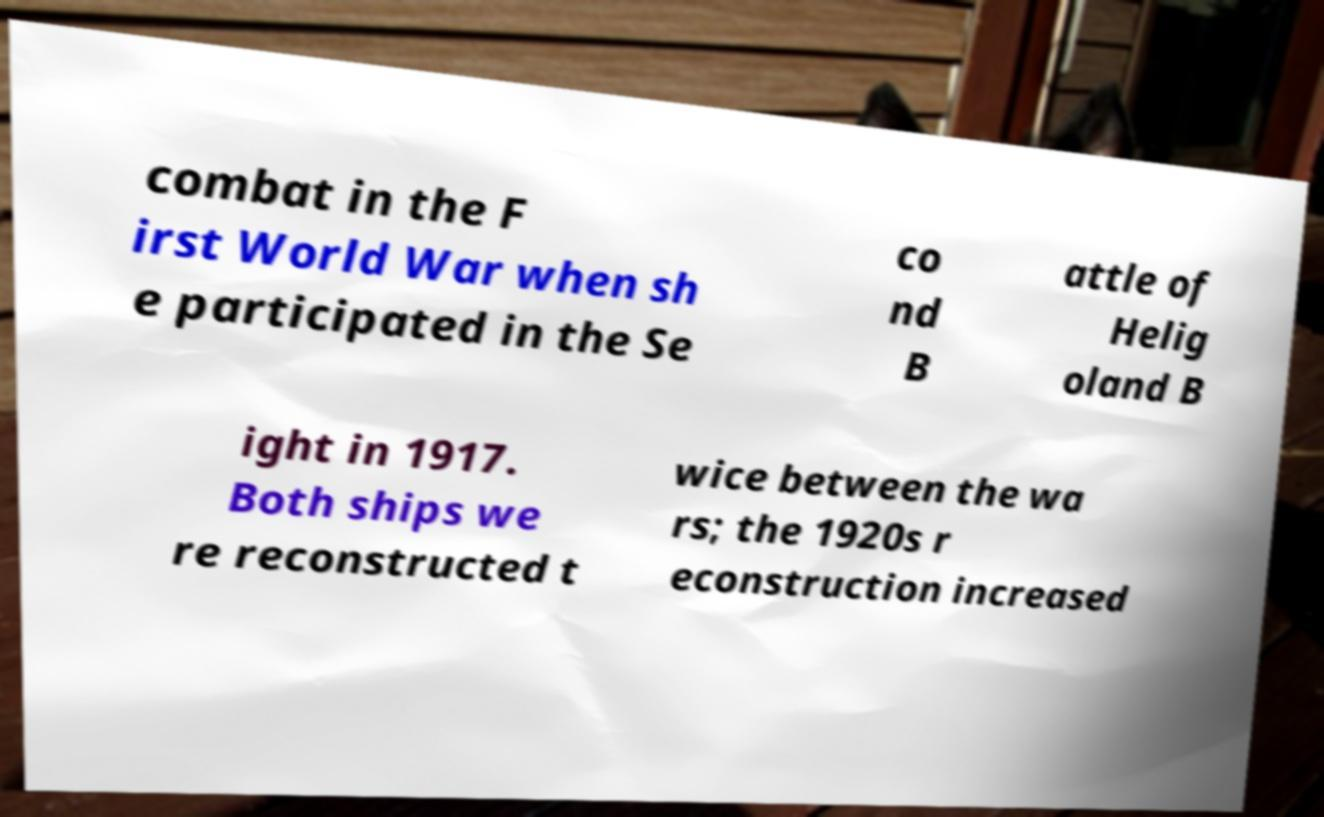There's text embedded in this image that I need extracted. Can you transcribe it verbatim? combat in the F irst World War when sh e participated in the Se co nd B attle of Helig oland B ight in 1917. Both ships we re reconstructed t wice between the wa rs; the 1920s r econstruction increased 